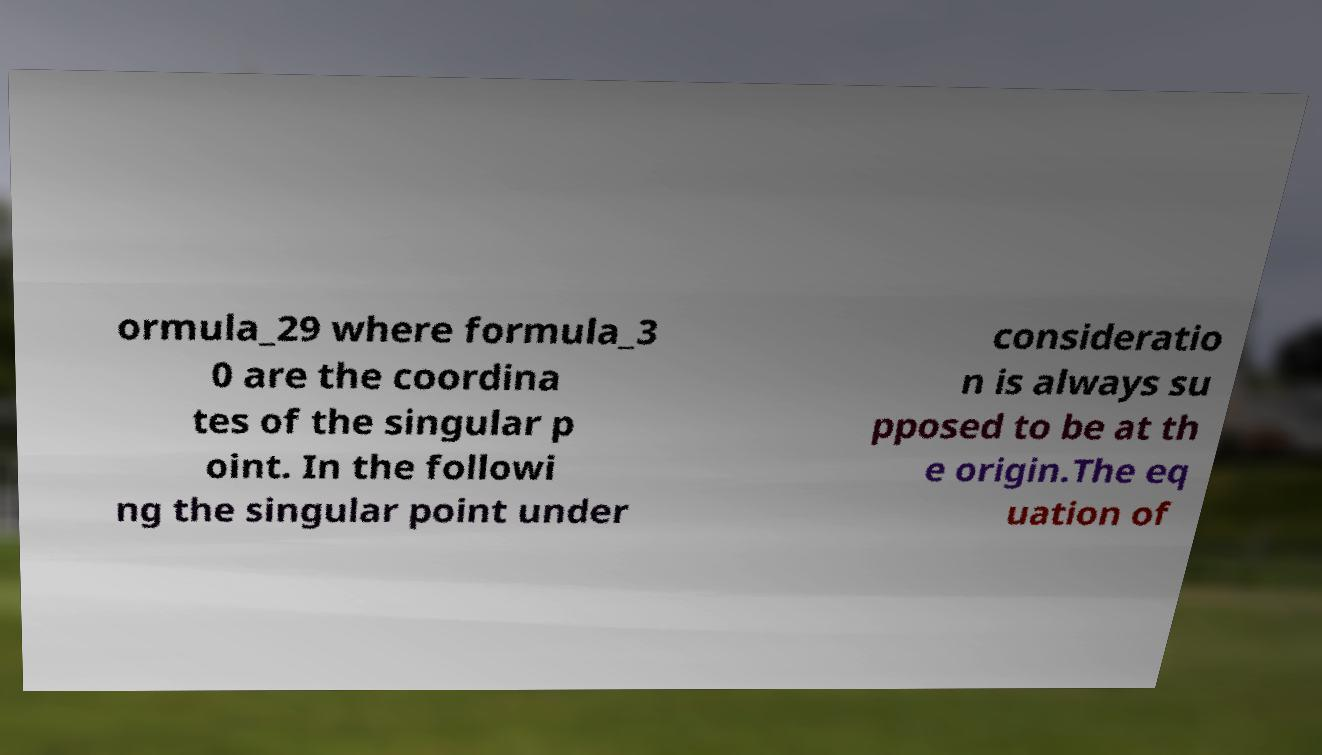There's text embedded in this image that I need extracted. Can you transcribe it verbatim? ormula_29 where formula_3 0 are the coordina tes of the singular p oint. In the followi ng the singular point under consideratio n is always su pposed to be at th e origin.The eq uation of 